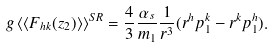<formula> <loc_0><loc_0><loc_500><loc_500>g \, \langle \langle F _ { h k } ( z _ { 2 } ) \rangle \rangle ^ { S R } = \frac { 4 } { 3 } \frac { \alpha _ { s } } { m _ { 1 } } \frac { 1 } { r ^ { 3 } } ( r ^ { h } p _ { 1 } ^ { k } - r ^ { k } p _ { 1 } ^ { h } ) .</formula> 